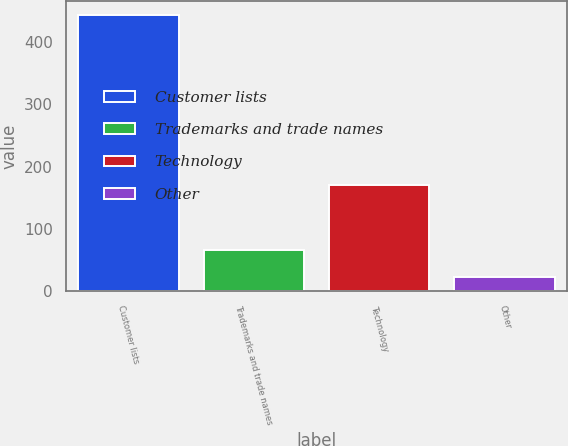Convert chart. <chart><loc_0><loc_0><loc_500><loc_500><bar_chart><fcel>Customer lists<fcel>Trademarks and trade names<fcel>Technology<fcel>Other<nl><fcel>444<fcel>66<fcel>170<fcel>24<nl></chart> 